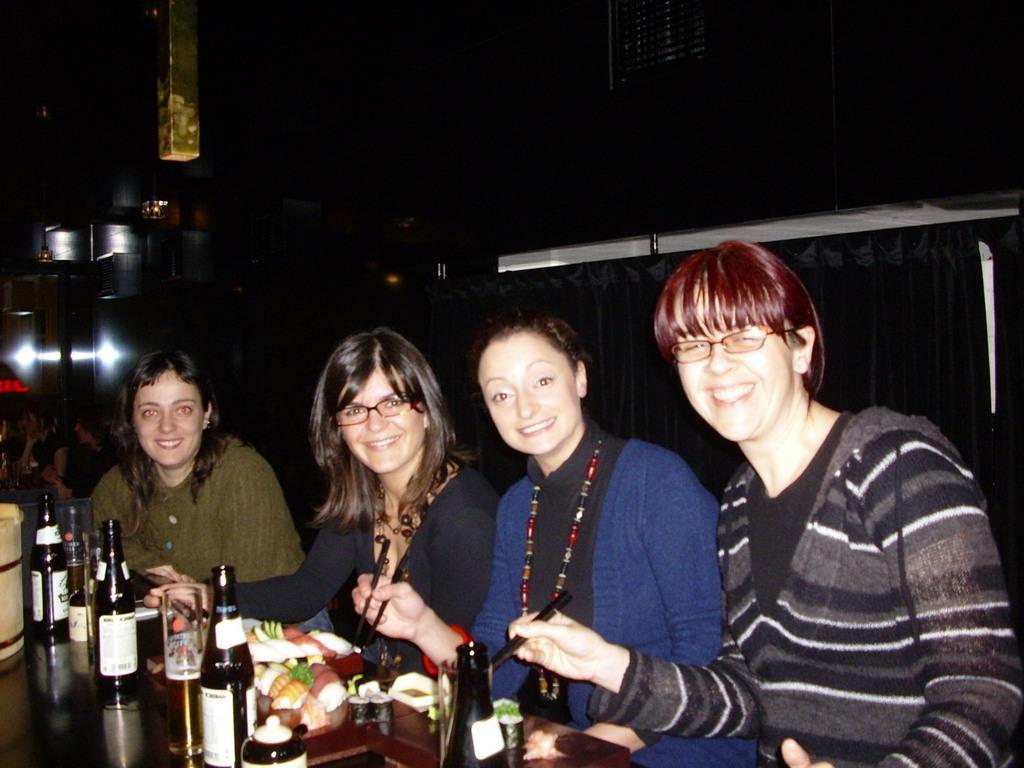Describe this image in one or two sentences. In this image there are group of people who are sitting, in front of them there is table. On the table there are some plates, bottles, glasses and in the plates there is some food. And in the background there are some persons, lights, wall and some other objects. 